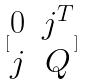<formula> <loc_0><loc_0><loc_500><loc_500>[ \begin{matrix} 0 & j ^ { T } \\ j & Q \end{matrix} ]</formula> 